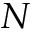<formula> <loc_0><loc_0><loc_500><loc_500>N</formula> 